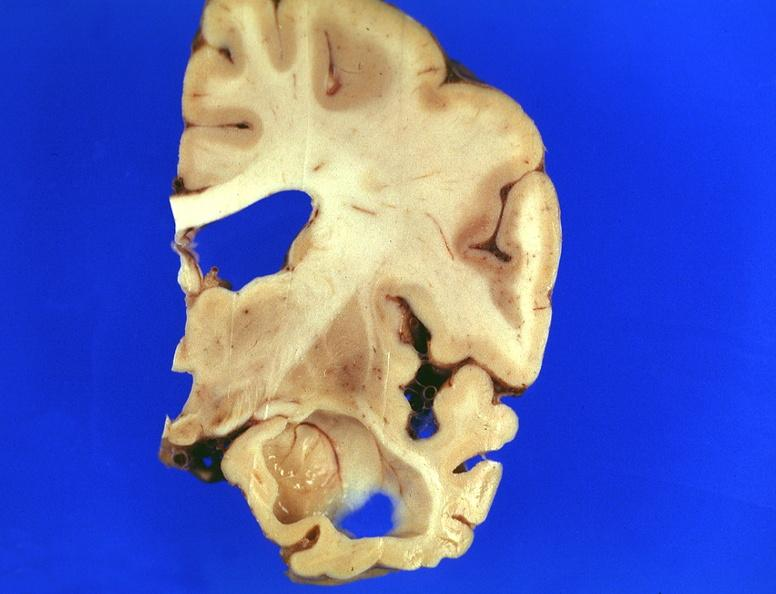what does this image show?
Answer the question using a single word or phrase. Brain 